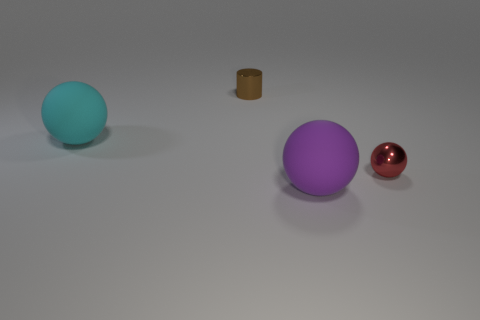Is the number of large purple matte spheres behind the big purple rubber object less than the number of small red metal objects that are in front of the small cylinder?
Provide a short and direct response. Yes. What number of balls are either tiny red shiny objects or rubber objects?
Ensure brevity in your answer.  3. Are the tiny object that is behind the big cyan rubber ball and the large object that is right of the brown metallic object made of the same material?
Provide a succinct answer. No. There is another shiny thing that is the same size as the red object; what shape is it?
Your answer should be compact. Cylinder. How many other objects are there of the same color as the metallic sphere?
Keep it short and to the point. 0. What number of cyan objects are big rubber spheres or metal balls?
Ensure brevity in your answer.  1. There is a big matte object that is in front of the red shiny object; is its shape the same as the shiny object that is to the right of the purple rubber sphere?
Provide a short and direct response. Yes. How many other things are made of the same material as the big purple thing?
Your answer should be compact. 1. There is a small brown metallic object that is behind the sphere behind the small red metallic thing; are there any objects to the right of it?
Keep it short and to the point. Yes. Does the cyan sphere have the same material as the big purple sphere?
Keep it short and to the point. Yes. 